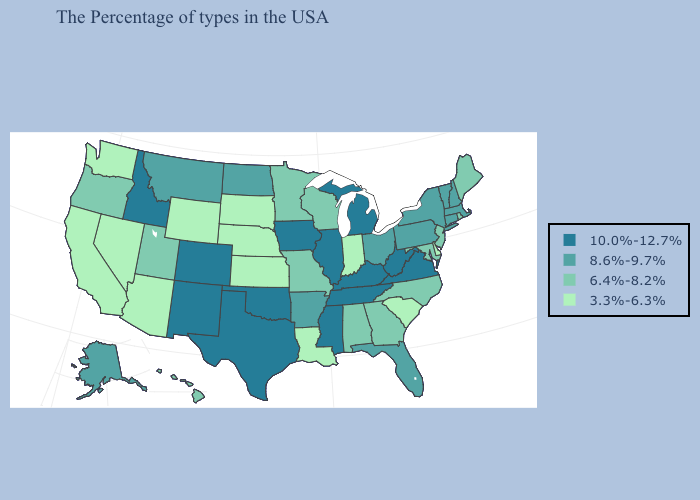Which states have the highest value in the USA?
Concise answer only. Virginia, West Virginia, Michigan, Kentucky, Tennessee, Illinois, Mississippi, Iowa, Oklahoma, Texas, Colorado, New Mexico, Idaho. What is the value of South Dakota?
Answer briefly. 3.3%-6.3%. Name the states that have a value in the range 3.3%-6.3%?
Short answer required. Delaware, South Carolina, Indiana, Louisiana, Kansas, Nebraska, South Dakota, Wyoming, Arizona, Nevada, California, Washington. Name the states that have a value in the range 10.0%-12.7%?
Keep it brief. Virginia, West Virginia, Michigan, Kentucky, Tennessee, Illinois, Mississippi, Iowa, Oklahoma, Texas, Colorado, New Mexico, Idaho. Does New Hampshire have the highest value in the USA?
Keep it brief. No. Name the states that have a value in the range 10.0%-12.7%?
Keep it brief. Virginia, West Virginia, Michigan, Kentucky, Tennessee, Illinois, Mississippi, Iowa, Oklahoma, Texas, Colorado, New Mexico, Idaho. What is the lowest value in the USA?
Give a very brief answer. 3.3%-6.3%. Name the states that have a value in the range 3.3%-6.3%?
Write a very short answer. Delaware, South Carolina, Indiana, Louisiana, Kansas, Nebraska, South Dakota, Wyoming, Arizona, Nevada, California, Washington. Does Washington have the lowest value in the USA?
Concise answer only. Yes. What is the highest value in states that border New Mexico?
Quick response, please. 10.0%-12.7%. Does Utah have the highest value in the West?
Short answer required. No. Does the first symbol in the legend represent the smallest category?
Give a very brief answer. No. What is the value of South Carolina?
Short answer required. 3.3%-6.3%. Name the states that have a value in the range 3.3%-6.3%?
Quick response, please. Delaware, South Carolina, Indiana, Louisiana, Kansas, Nebraska, South Dakota, Wyoming, Arizona, Nevada, California, Washington. What is the value of Rhode Island?
Answer briefly. 6.4%-8.2%. 